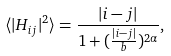<formula> <loc_0><loc_0><loc_500><loc_500>\langle | H _ { i j } | ^ { 2 } \rangle = \frac { | i - j | } { 1 + ( \frac { | i - j | } { b } ) ^ { 2 \alpha } } ,</formula> 